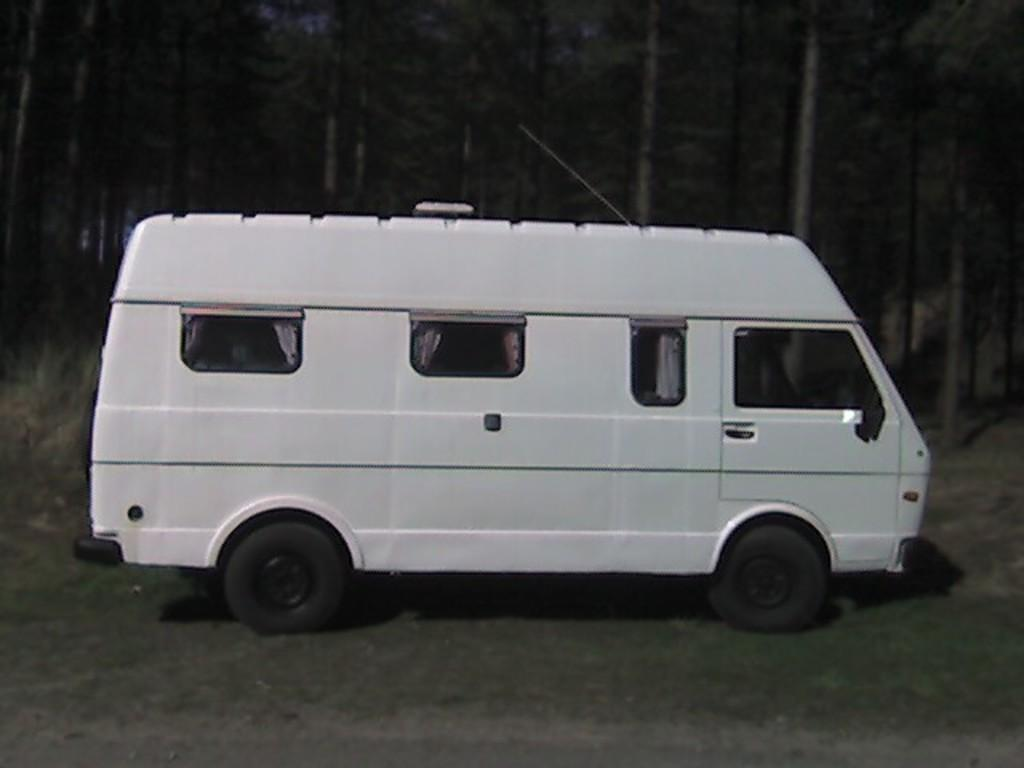What type of vehicle is in the image? There is a white color van in the image. Where is the van located? The van is on the ground. What can be seen in the background of the image? There are tall trees in the background of the image. What is attached to the top of the van? There is an antenna above the van. Where are the kittens playing at the seashore in the image? There are no kittens or seashore present in the image; it features a white color van on the ground with tall trees in the background and an antenna above the van. 